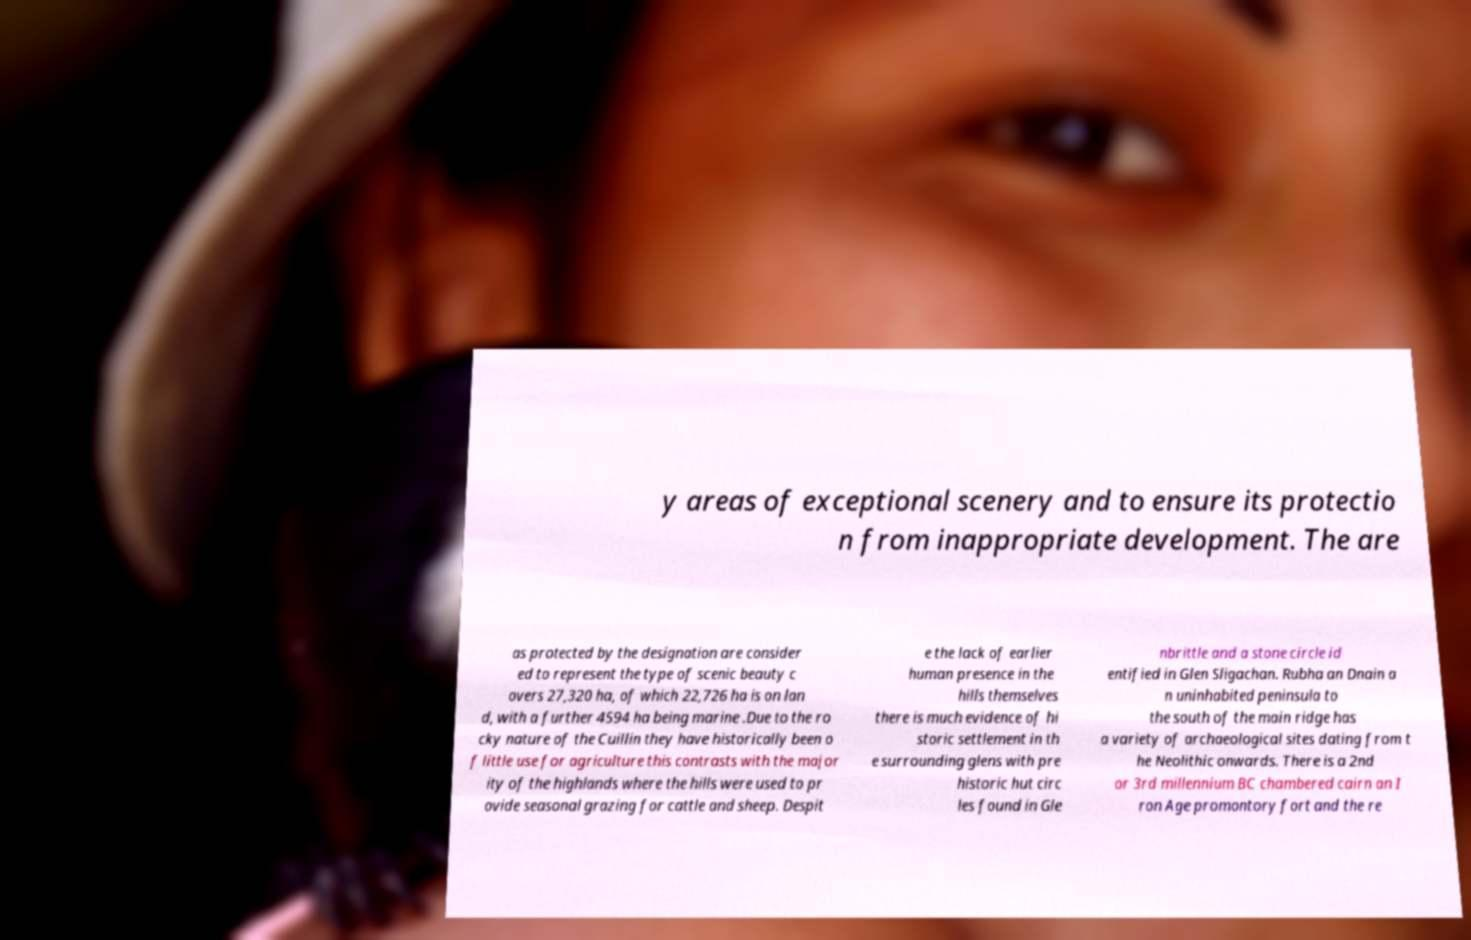Could you assist in decoding the text presented in this image and type it out clearly? y areas of exceptional scenery and to ensure its protectio n from inappropriate development. The are as protected by the designation are consider ed to represent the type of scenic beauty c overs 27,320 ha, of which 22,726 ha is on lan d, with a further 4594 ha being marine .Due to the ro cky nature of the Cuillin they have historically been o f little use for agriculture this contrasts with the major ity of the highlands where the hills were used to pr ovide seasonal grazing for cattle and sheep. Despit e the lack of earlier human presence in the hills themselves there is much evidence of hi storic settlement in th e surrounding glens with pre historic hut circ les found in Gle nbrittle and a stone circle id entified in Glen Sligachan. Rubha an Dnain a n uninhabited peninsula to the south of the main ridge has a variety of archaeological sites dating from t he Neolithic onwards. There is a 2nd or 3rd millennium BC chambered cairn an I ron Age promontory fort and the re 